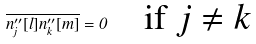Convert formula to latex. <formula><loc_0><loc_0><loc_500><loc_500>\overline { n ^ { \prime \prime } _ { j } [ l ] n ^ { \prime \prime } _ { k } [ m ] } = 0 \quad \text {if $j\neq k$}</formula> 